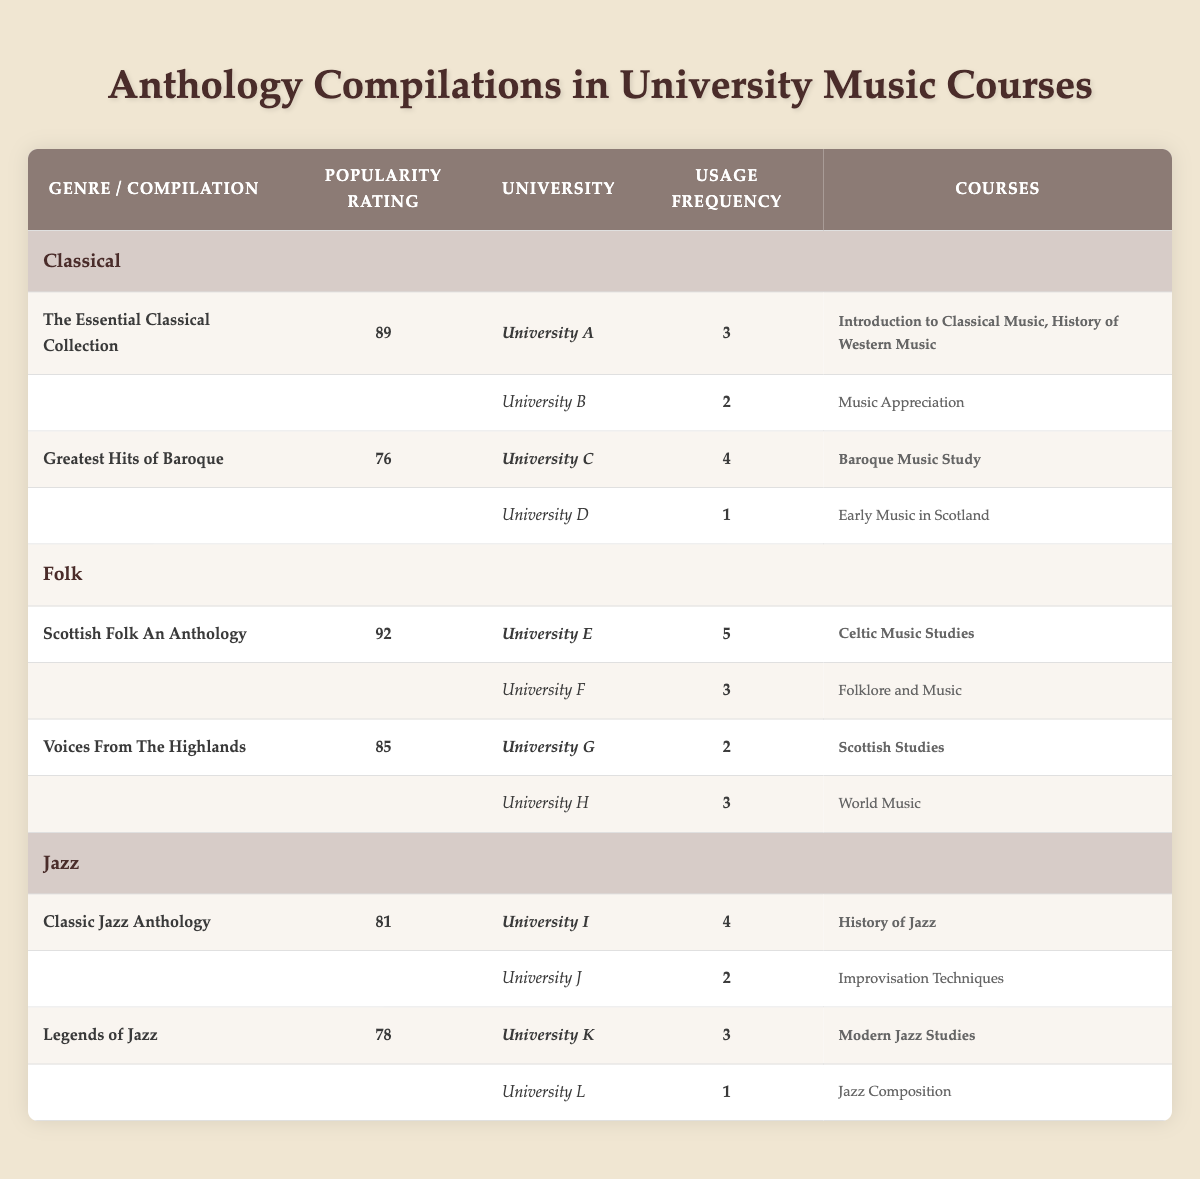What is the highest popularity rating among the anthology compilations? The table shows that "Scottish Folk An Anthology" has the highest popularity rating of 92.
Answer: 92 Which university utilizes "The Essential Classical Collection" the most frequently? Looking at the course utilization for "The Essential Classical Collection," University A has the highest usage frequency of 3.
Answer: University A What is the total usage frequency for the "Jazz" genre compilations? The total usage frequency is the sum of the usage frequencies of the two compilations: "Classic Jazz Anthology" (4) + "Legends of Jazz" (3), which equals 7.
Answer: 7 Is "Voices From The Highlands" utilized in more than one university? The table indicates "Voices From The Highlands" is utilized in University G and University H, which means it is used in more than one university.
Answer: Yes What is the average popularity rating for the Folk genre compilations? The average popularity rating is calculated by summing the popularity ratings of the two compilations, which is 92 (Scottish Folk An Anthology) + 85 (Voices From The Highlands) = 177, then dividing by the number of compilations (2): 177/2 = 88.5.
Answer: 88.5 Which compilation has a popularity rating lower than 80, and how many universities use it? The compilation "Legends of Jazz" has a popularity rating of 78, and it is used in 2 universities (University K and University L).
Answer: 2 How many courses are associated with the "Greatest Hits of Baroque" compilation at all universities? The "Greatest Hits of Baroque" is utilized in University C for 1 course and in University D for 1 course, giving a total of 2 courses associated with this compilation.
Answer: 2 Which university has the lowest usage frequency for the "Folk" genre compilations? "Voices From The Highlands" has the lowest usage frequency of 2 at University G, which is lower than the frequencies for both compilations under the Folk genre at other universities.
Answer: University G How many different courses incorporate the "Classic Jazz Anthology"? The "Classic Jazz Anthology" is incorporated into 2 courses at University I and 1 course at University J, totaling 3 different courses.
Answer: 3 